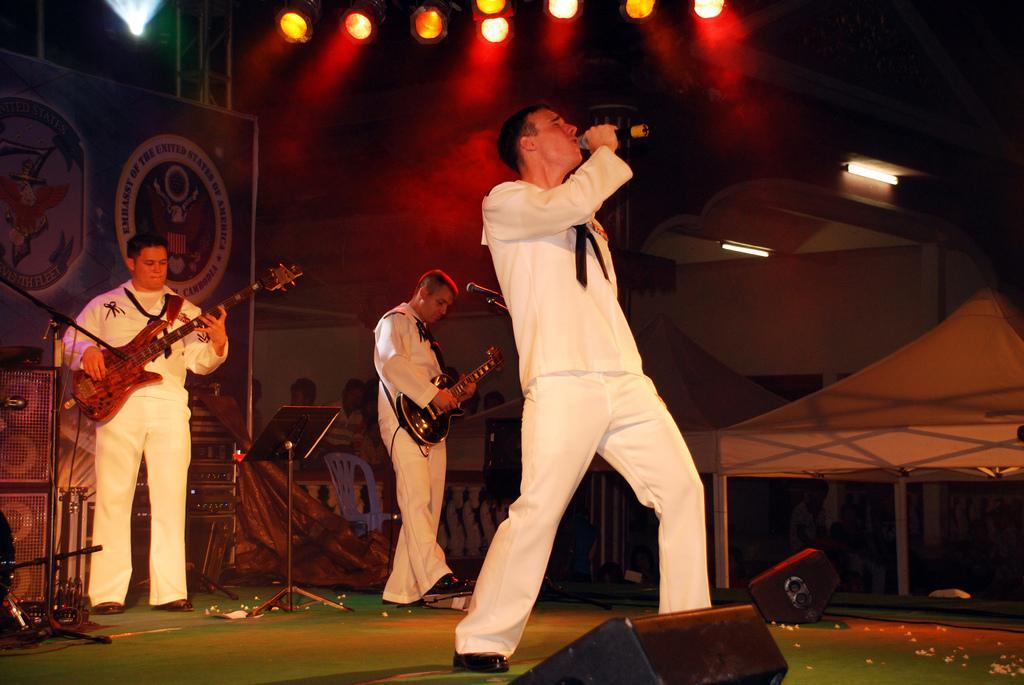In one or two sentences, can you explain what this image depicts? In this picture there are three musicians. Among them two people are playing guitar and a guy is singing song with a mic in his hand. In the background we observe red color lights attached to the roof. 